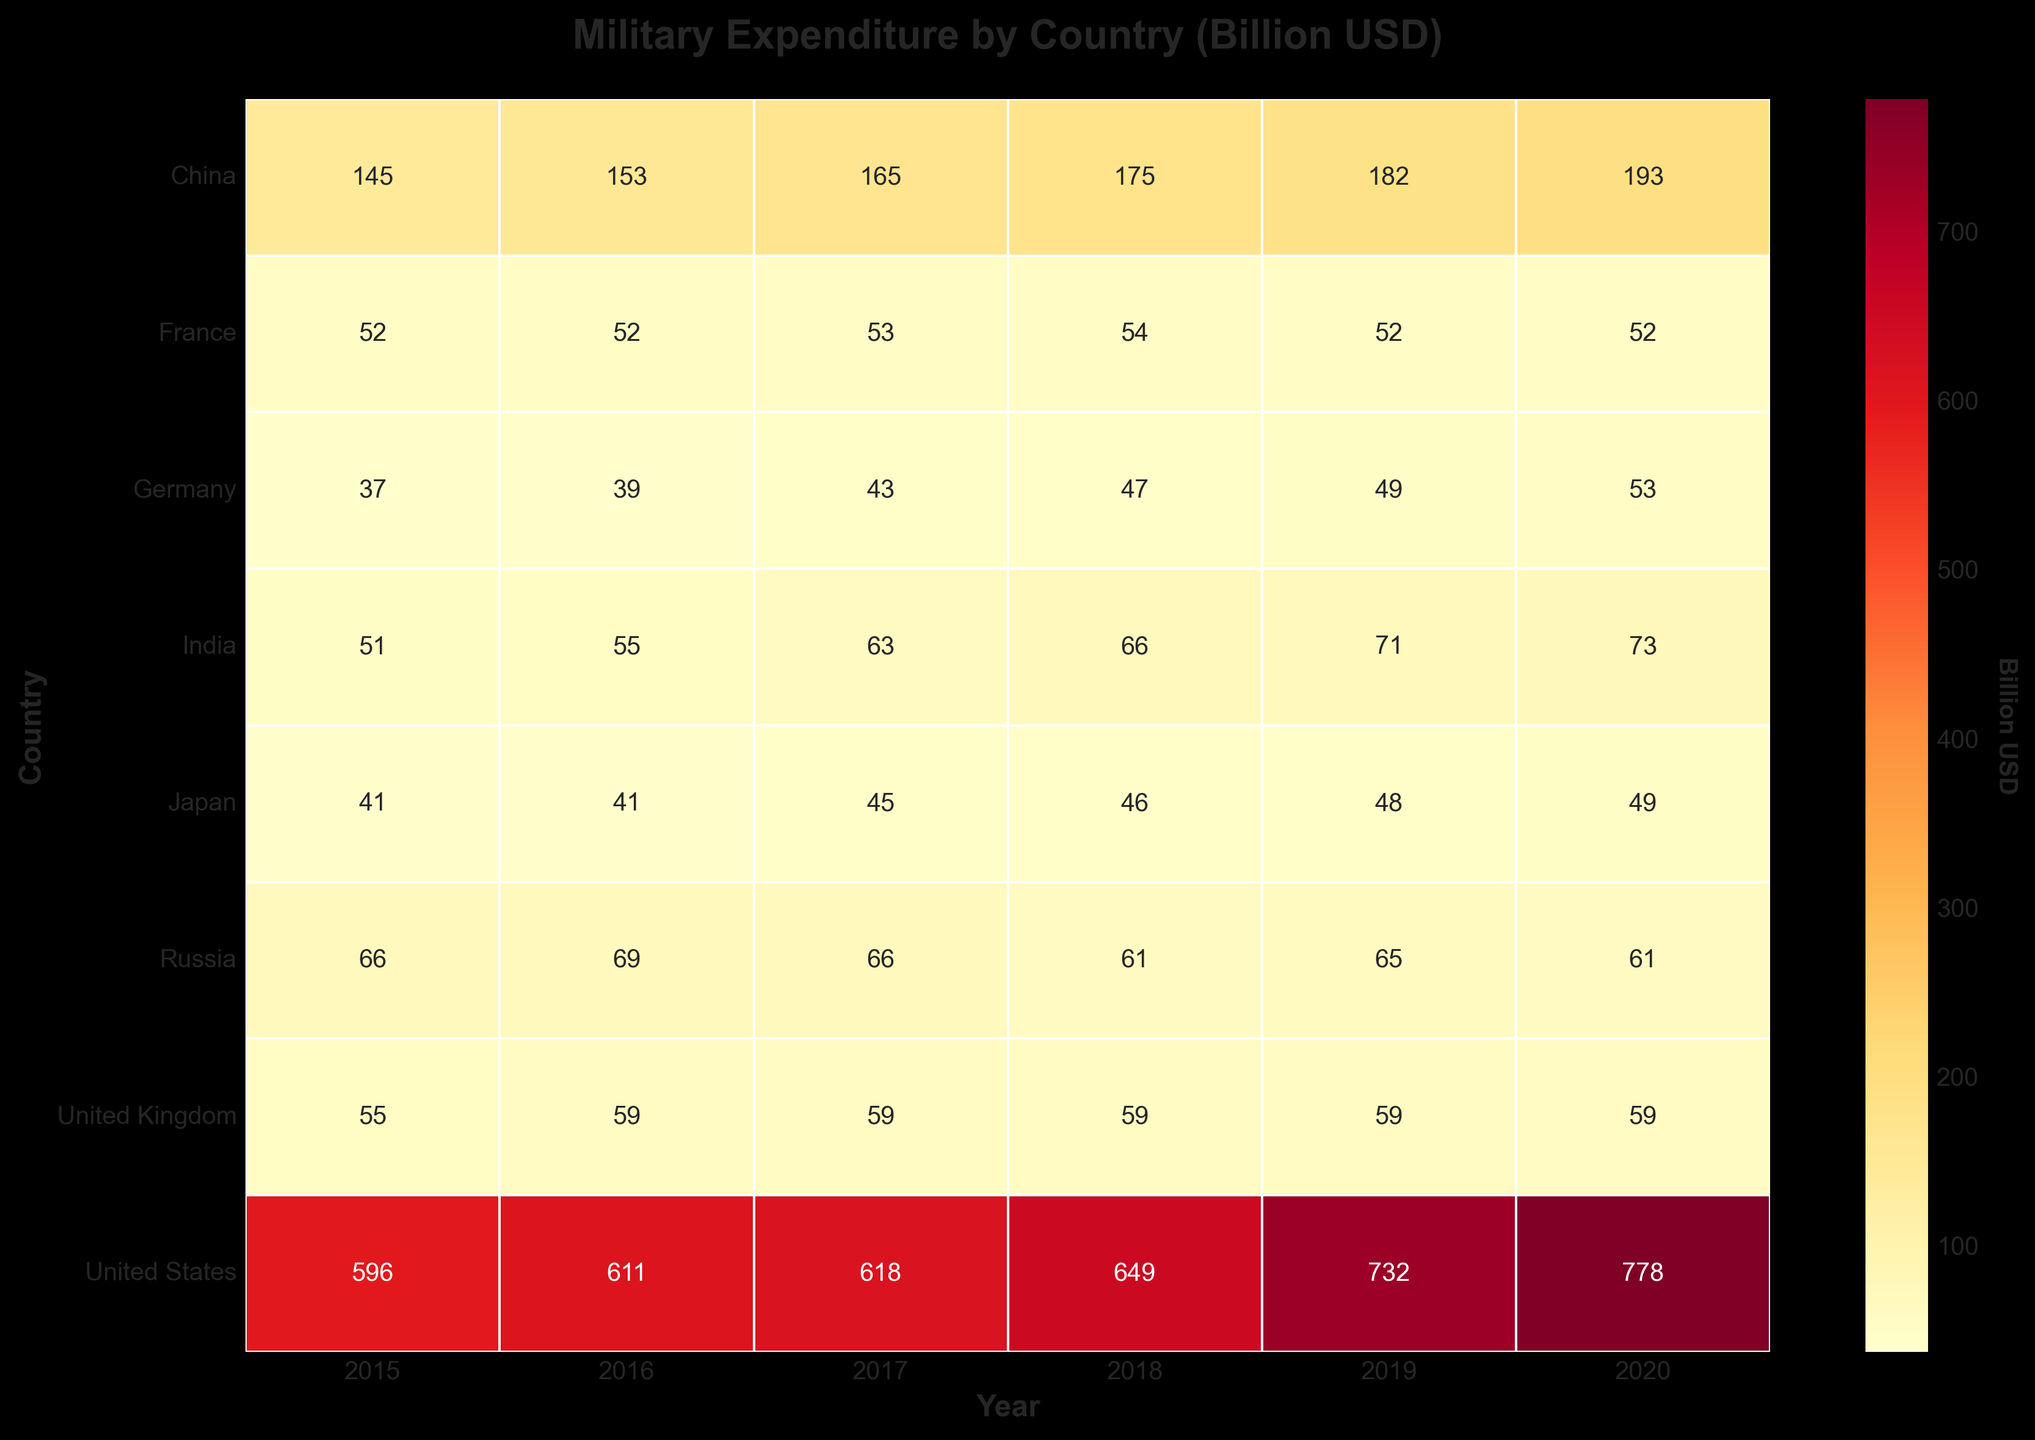What is the title of the figure? The title of the figure is the text at the top of the plot. It usually provides a brief description of what the plot represents. In this case, the title is "Military Expenditure by Country (Billion USD)" as mentioned in the code.
Answer: Military Expenditure by Country (Billion USD) Which country has the highest military expenditure in 2020 based on the heatmap? To find the highest military expenditure in 2020, look at the heatmap under the column labeled '2020' and find the highest value. The United States has the highest value at 778 billion USD.
Answer: United States How much did China's military expenditure increase from 2015 to 2020? Find China's military expenditure for 2015 and 2020 from the heatmap. The values are 145 billion USD and 193 billion USD, respectively. The increase is 193 - 145 = 48 billion USD.
Answer: 48 billion USD Among all the countries listed, which country had the lowest military expenditure in 2015? Look at the 2015 column in the heatmap and identify the lowest value. Germany has the lowest military expenditure in 2015 with 37 billion USD.
Answer: Germany Which year saw the largest increase in military expenditure for the United States? Compare the year-over-year military expenditure values for the United States. The largest increase is from 2018 to 2019, where the expenditure increased from 649 billion USD to 732 billion USD.
Answer: 2019 What is the average military expenditure of France from 2015 to 2020? Add up all the military expenditure values for France from 2015 to 2020 and divide by the number of years. (52 + 52 + 53 + 54 + 52 + 52) / 6 = 52.5 billion USD.
Answer: 52.5 billion USD Which two countries have the same value of military expenditure for any given year? Look through the heatmap to identify any matching values. The United Kingdom and France both have a military expenditure of 52 billion USD in 2015 and 2020.
Answer: United Kingdom and France How does the military expenditure trend of Russia compare to that of China from 2015 to 2020? Look at the year-wise values for both countries from the heatmap. Russia's expenditure decreased from 66 billion USD in 2015 to 61 billion in 2020, while China’s expenditure increased from 145 billion USD in 2015 to 193 billion USD in 2020, showing opposite trends.
Answer: Opposite trends What is the difference in military expenditure between India and Japan in 2020? Refer to the 2020 column in the heatmap and find the values for India and Japan. The values are 73 billion USD for India and 49 billion USD for Japan. The difference is 73 - 49 = 24 billion USD.
Answer: 24 billion USD 